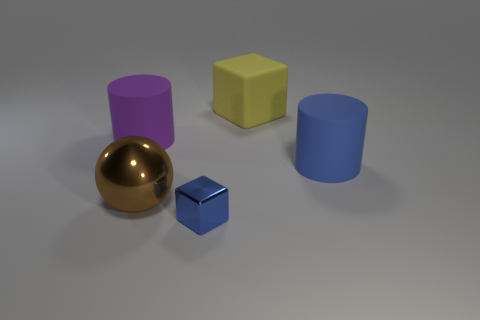There is a large blue thing; is it the same shape as the big matte object that is on the left side of the large yellow rubber block?
Keep it short and to the point. Yes. What number of things are either big matte objects or purple matte objects that are behind the big ball?
Your answer should be very brief. 3. There is another thing that is the same shape as the large yellow object; what is its material?
Make the answer very short. Metal. Is the shape of the rubber thing to the left of the big yellow block the same as  the small blue metal object?
Give a very brief answer. No. Are there any other things that have the same size as the blue shiny block?
Ensure brevity in your answer.  No. Are there fewer small blue cubes behind the small thing than brown objects left of the yellow rubber cube?
Your answer should be very brief. Yes. How many other objects are there of the same shape as the brown metallic object?
Make the answer very short. 0. There is a rubber thing in front of the large cylinder that is left of the big cylinder that is to the right of the big yellow thing; what is its size?
Offer a very short reply. Large. What number of purple objects are either rubber spheres or big rubber objects?
Your response must be concise. 1. What is the shape of the matte object behind the matte cylinder left of the brown metal thing?
Give a very brief answer. Cube. 